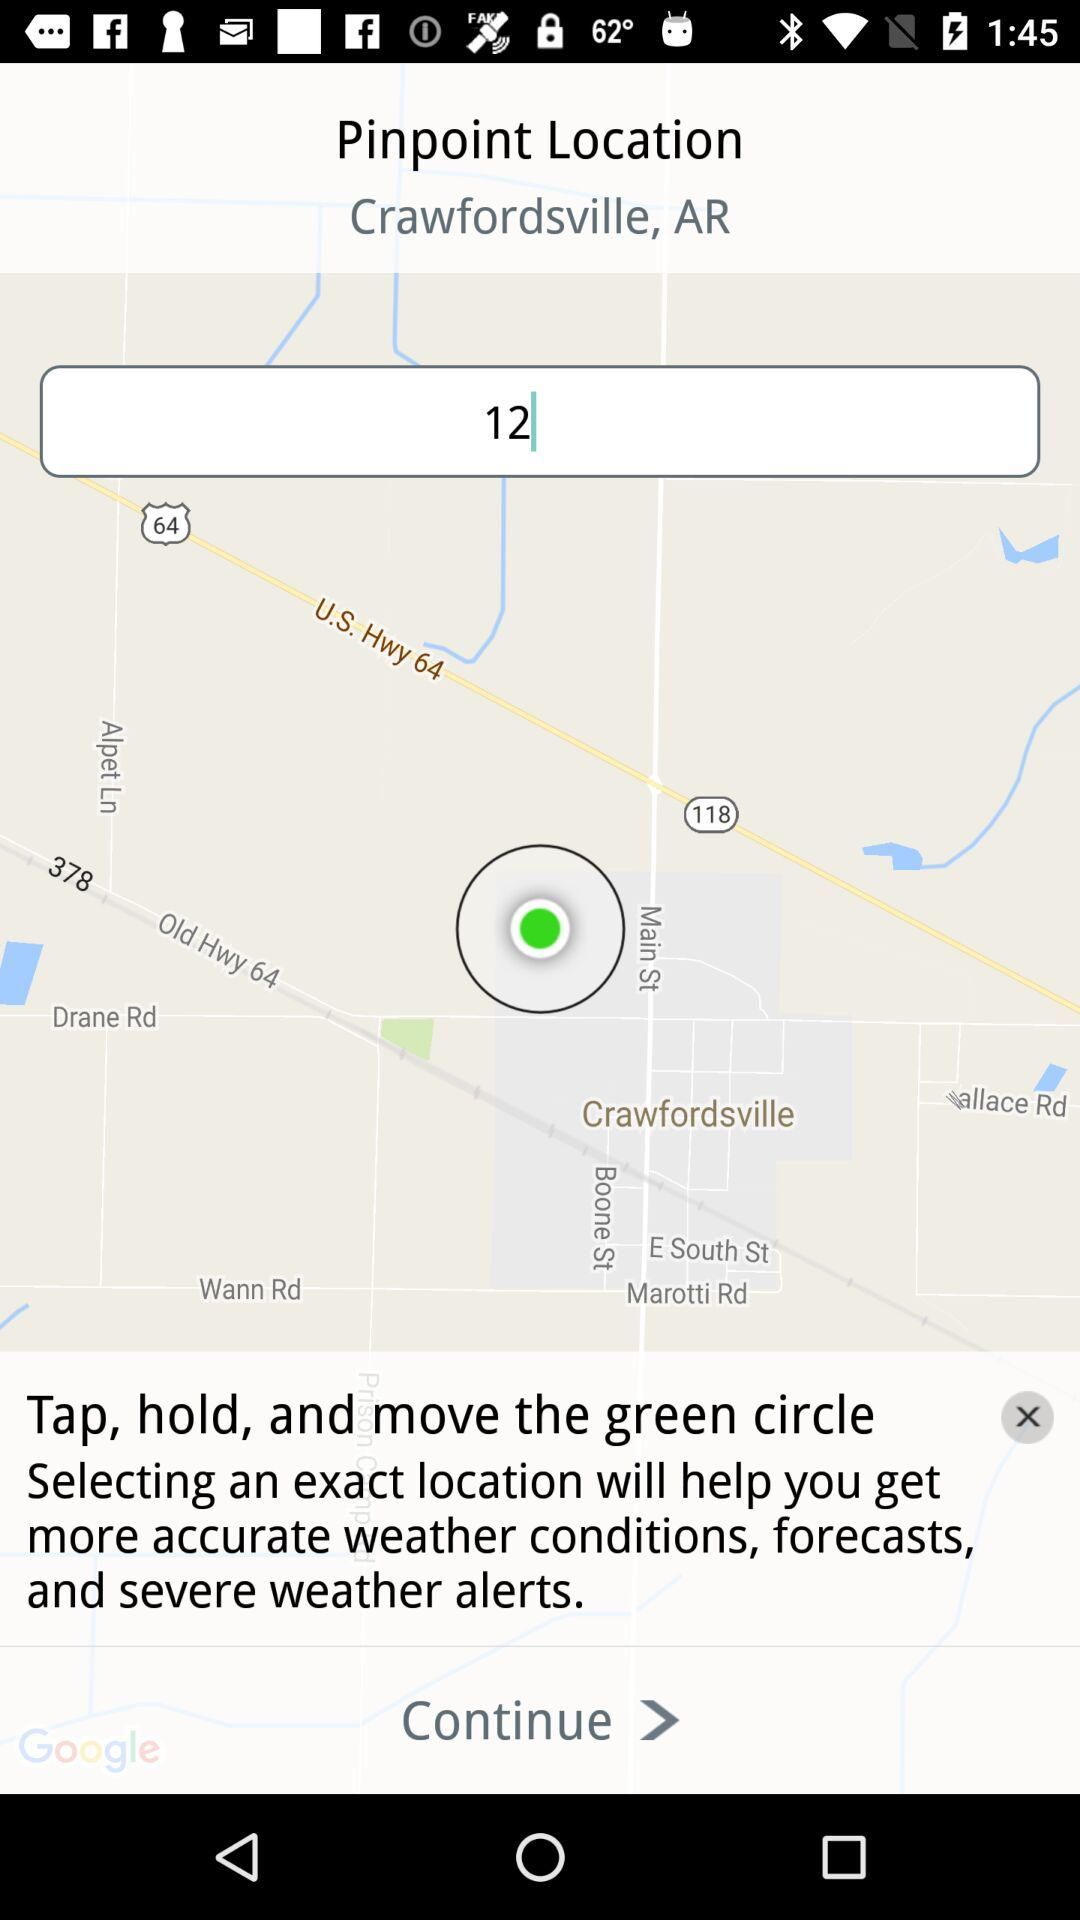How many text inputs are on the screen?
Answer the question using a single word or phrase. 1 